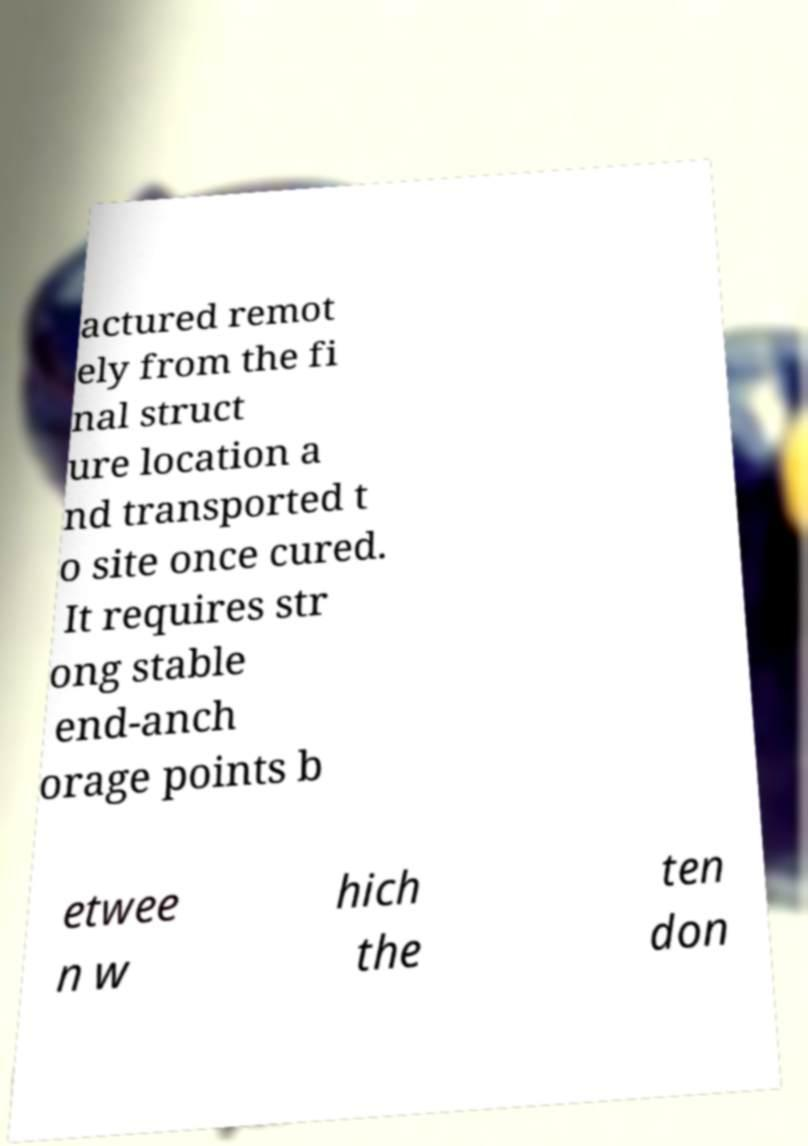I need the written content from this picture converted into text. Can you do that? actured remot ely from the fi nal struct ure location a nd transported t o site once cured. It requires str ong stable end-anch orage points b etwee n w hich the ten don 